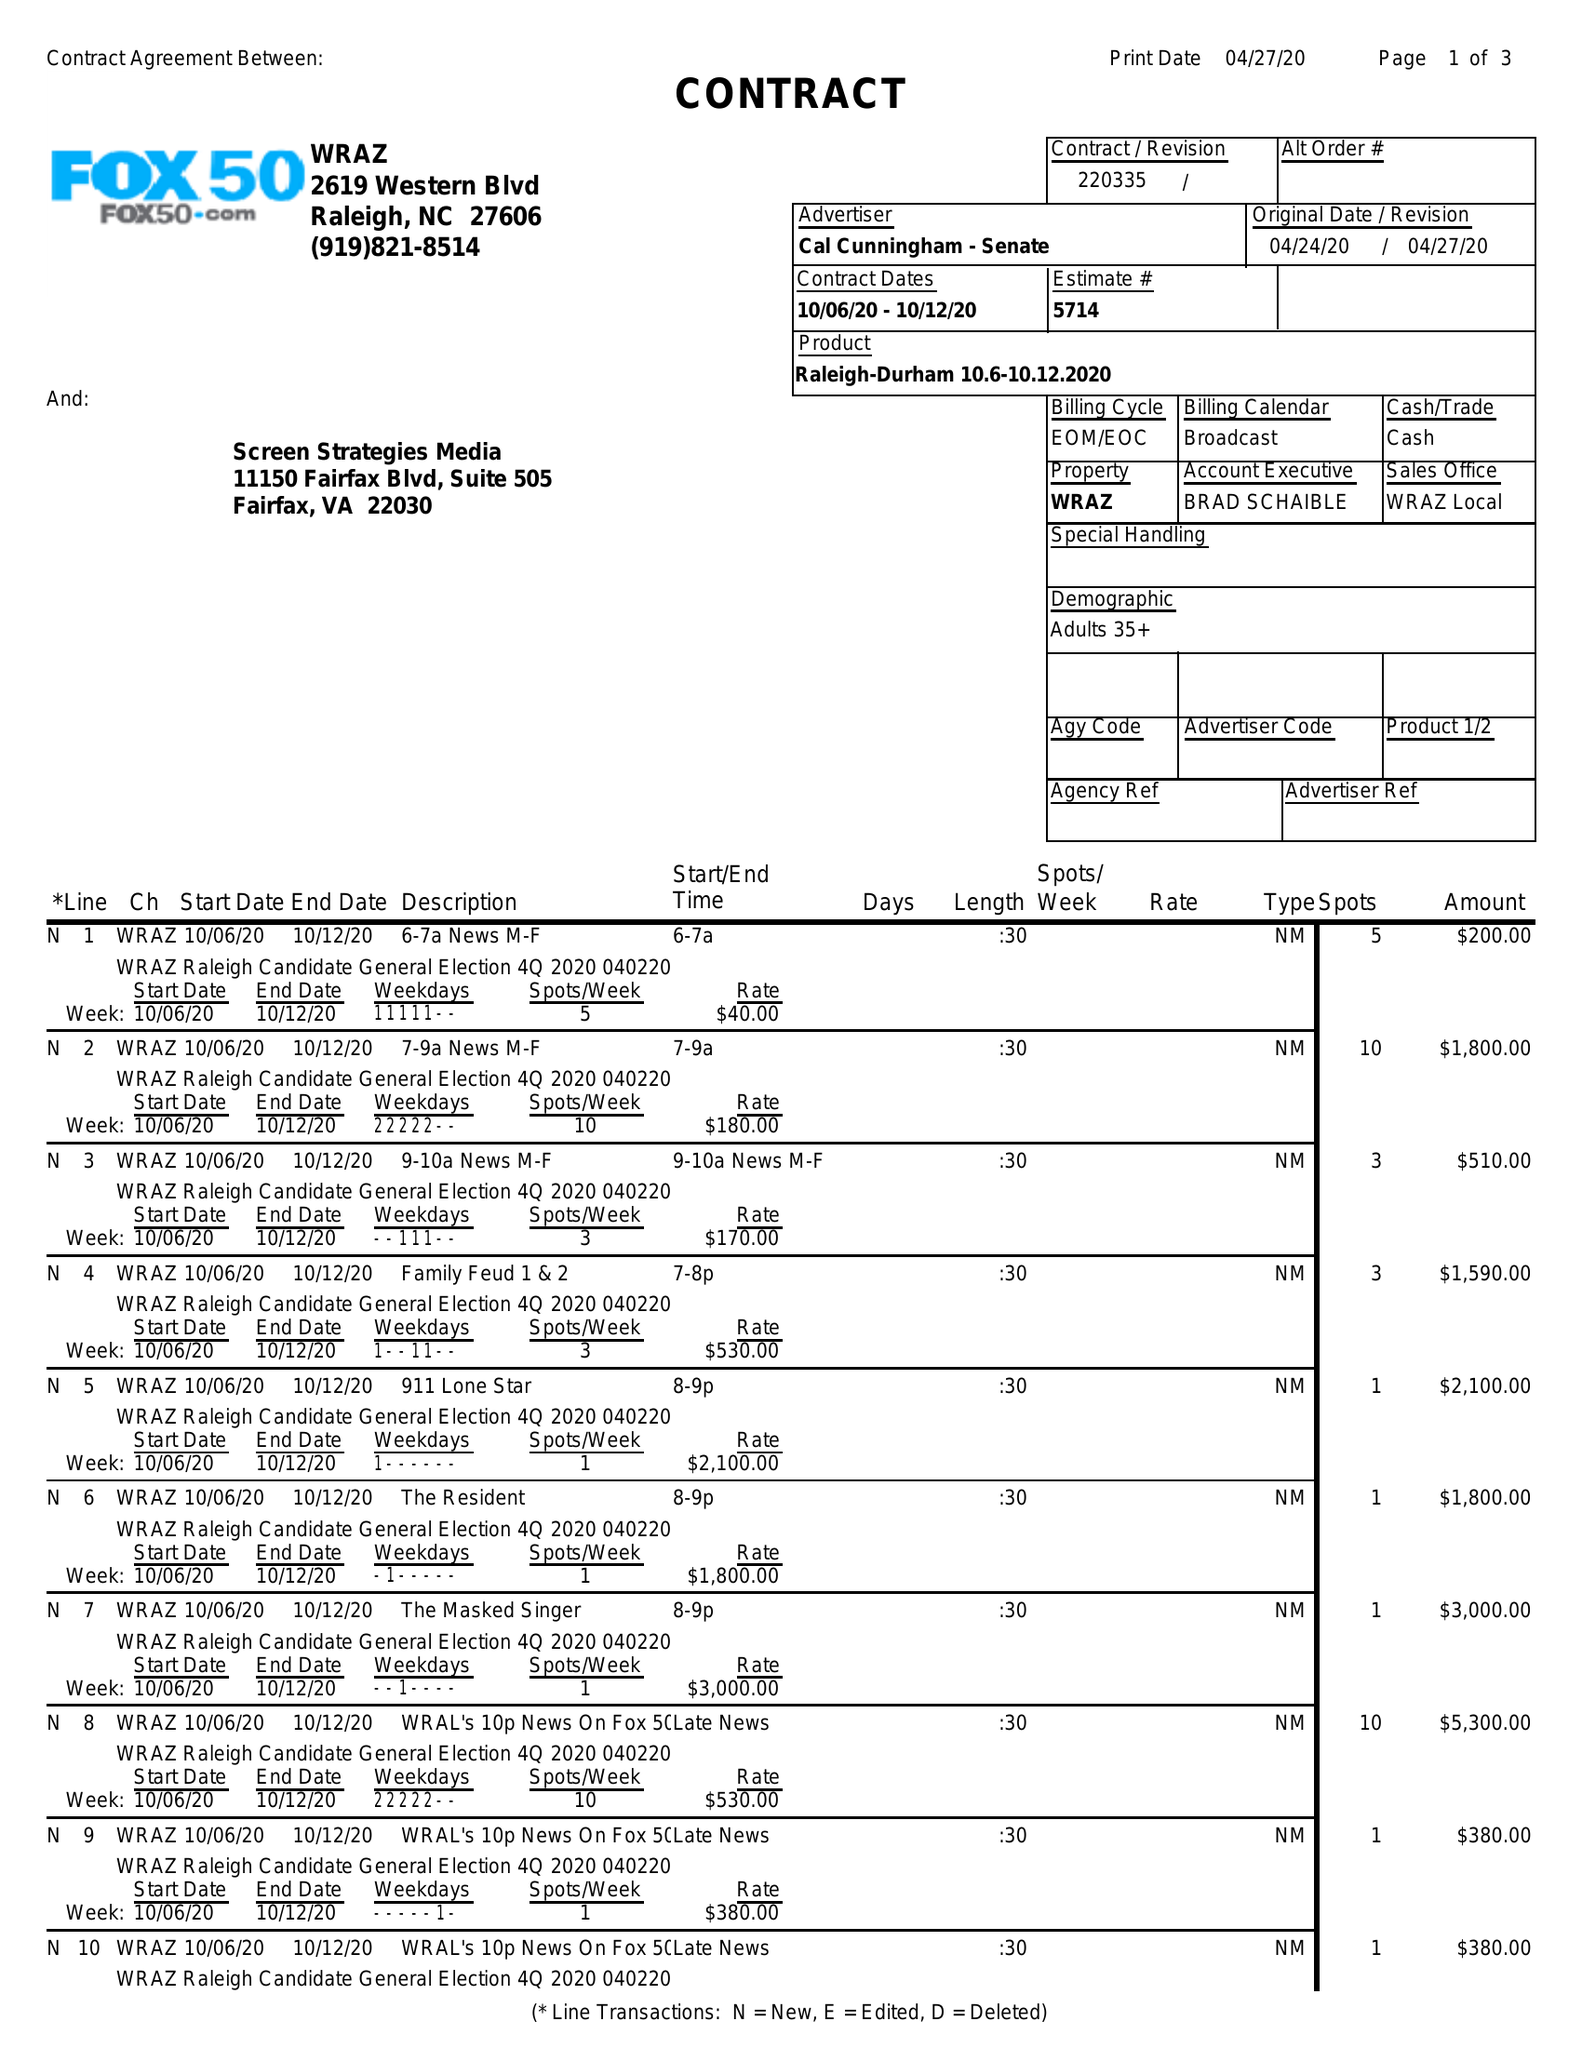What is the value for the advertiser?
Answer the question using a single word or phrase. CAL CUNNINGHAM - SENATE 